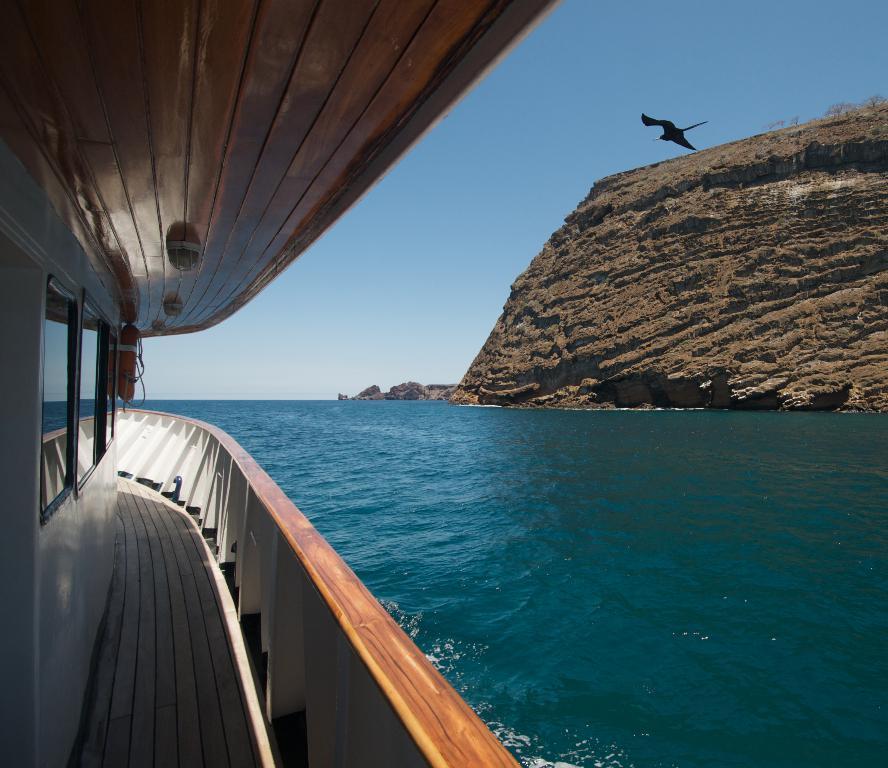Could you give a brief overview of what you see in this image? In this picture, there is a boat towards the left. Beside it, there is an ocean. Towards the right, there is a hill. At the top, there is a bird flying towards the left. In the background, there is a sky. 